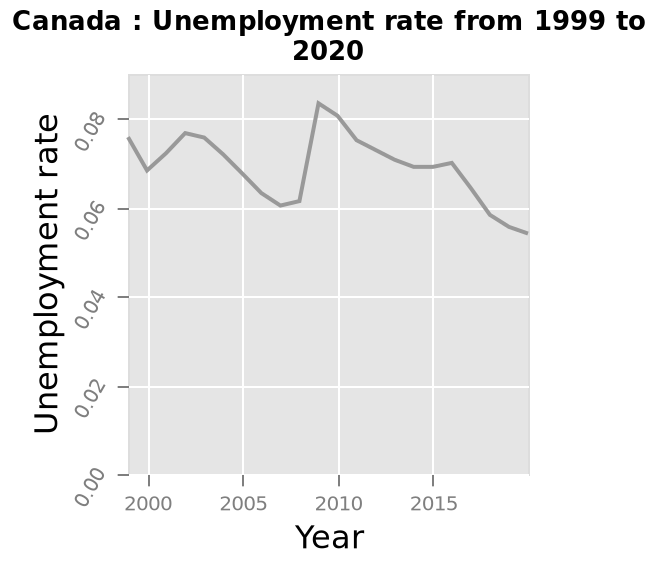<image>
please summary the statistics and relations of the chart The unemployment rate has defined peaks and troughs.  2020 has the lowest rate of unemployment with 2003 being the previous low. Unemployment was at it's highest in 2009. Unemployment rates in Canada appear to stay within a margin of 0.08 - 0.06. What is the range of the x-axis on the line plot? The x-axis on the line plot has a range from 1999 to 2020. What is the title of the line plot?  The title of the line plot is "Canada : Unemployment rate from 1999 to 2020." What is the previous low unemployment rate before 2020?  The previous low unemployment rate before 2020 was in 2003. 